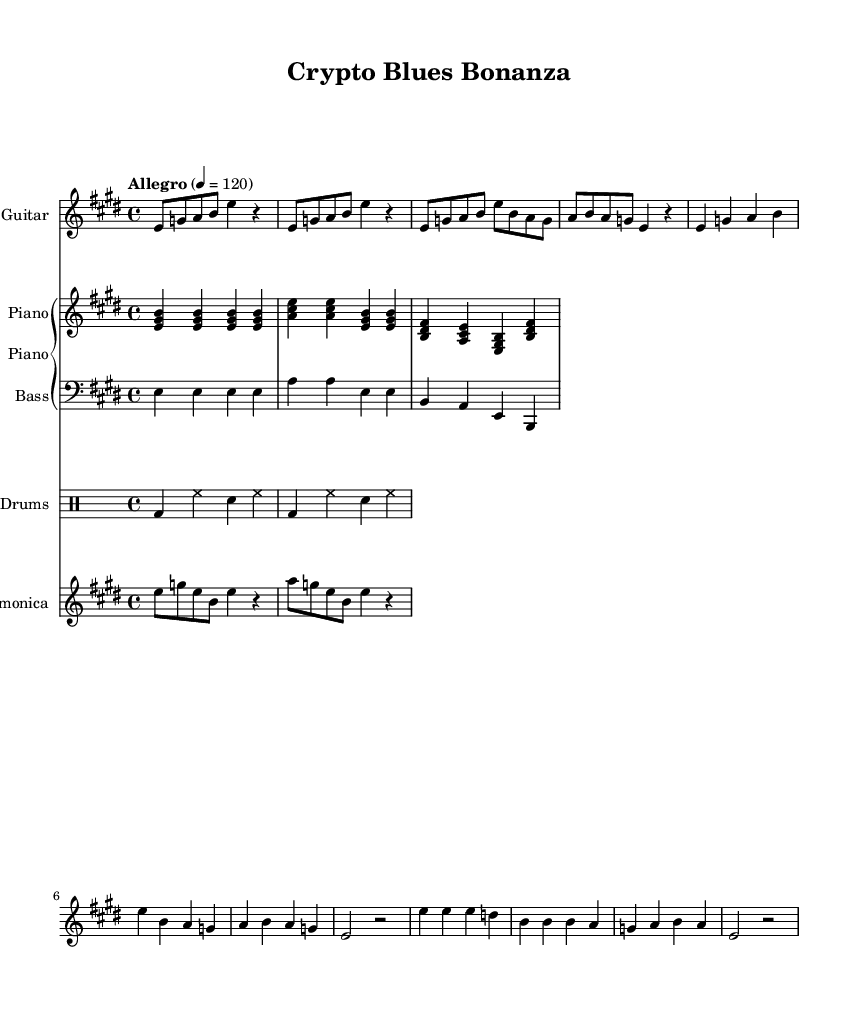what is the key signature of this music? The key signature is E major, which has four sharps (F#, C#, G#, D#).
Answer: E major what is the time signature of this blues? The time signature is 4/4, meaning there are four beats per measure.
Answer: 4/4 what is the tempo marking for this piece? The tempo marking is "Allegro," which indicates a quick and lively tempo.
Answer: Allegro how many measures are in the guitar section? There are 8 measures in the guitar section as observed from the layout of the music.
Answer: 8 what is the primary instrument used in the harmonica part? The primary instrument used is the Harmonica, as denoted in the staff name.
Answer: Harmonica considering the chord progression, which chord appears most frequently? The chord E major appears most frequently in the progression throughout the piece.
Answer: E major how does the bass line relate to the chord progression? The bass line outlines the root notes of the chords, primarily E, A, and B, reinforcing the harmony.
Answer: E, A, B 